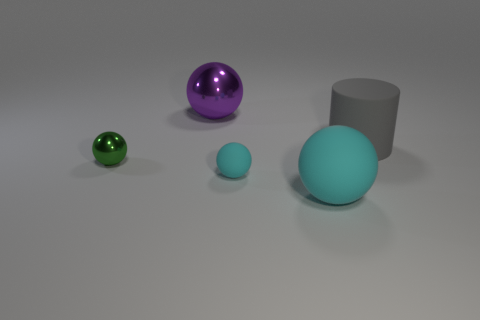Add 4 small cyan spheres. How many objects exist? 9 Subtract all brown spheres. Subtract all yellow cubes. How many spheres are left? 4 Subtract all balls. How many objects are left? 1 Add 1 big matte cylinders. How many big matte cylinders exist? 2 Subtract 0 yellow spheres. How many objects are left? 5 Subtract all big blue balls. Subtract all large gray things. How many objects are left? 4 Add 3 small green objects. How many small green objects are left? 4 